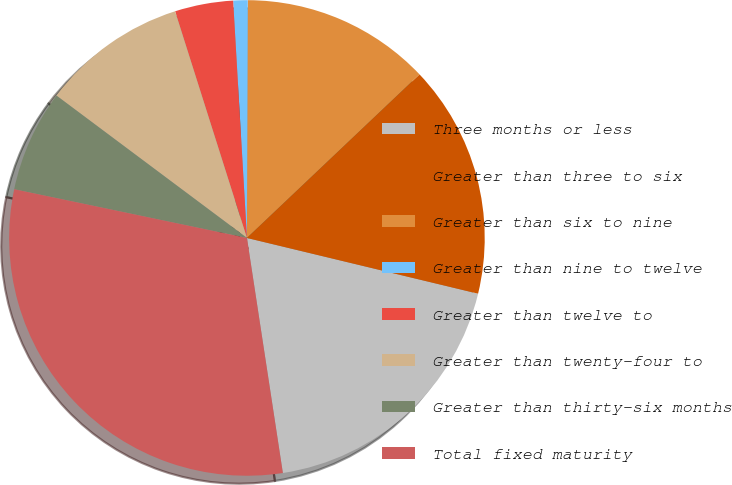Convert chart. <chart><loc_0><loc_0><loc_500><loc_500><pie_chart><fcel>Three months or less<fcel>Greater than three to six<fcel>Greater than six to nine<fcel>Greater than nine to twelve<fcel>Greater than twelve to<fcel>Greater than twenty-four to<fcel>Greater than thirty-six months<fcel>Total fixed maturity<nl><fcel>18.82%<fcel>15.84%<fcel>12.87%<fcel>0.98%<fcel>3.96%<fcel>9.9%<fcel>6.93%<fcel>30.7%<nl></chart> 